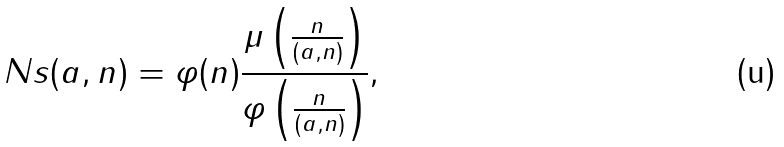<formula> <loc_0><loc_0><loc_500><loc_500>N s ( a , n ) = \varphi ( n ) \frac { \mu \left ( \frac { n } { ( a , n ) } \right ) } { \varphi \left ( \frac { n } { ( a , n ) } \right ) } ,</formula> 